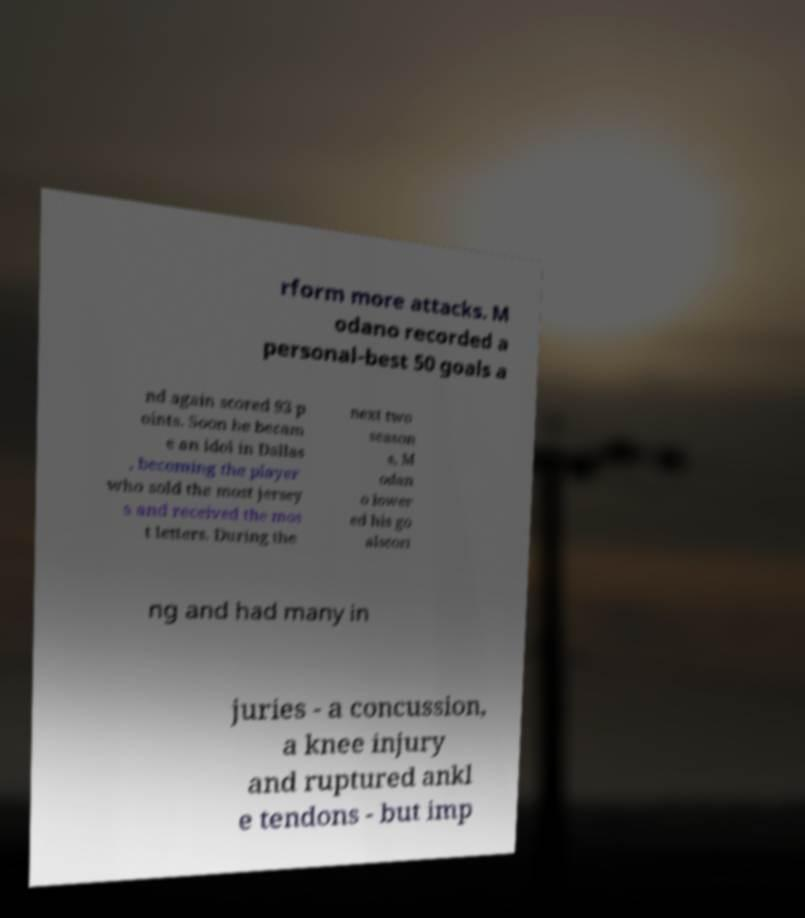For documentation purposes, I need the text within this image transcribed. Could you provide that? rform more attacks. M odano recorded a personal-best 50 goals a nd again scored 93 p oints. Soon he becam e an idol in Dallas , becoming the player who sold the most jersey s and received the mos t letters. During the next two season s, M odan o lower ed his go alscori ng and had many in juries - a concussion, a knee injury and ruptured ankl e tendons - but imp 